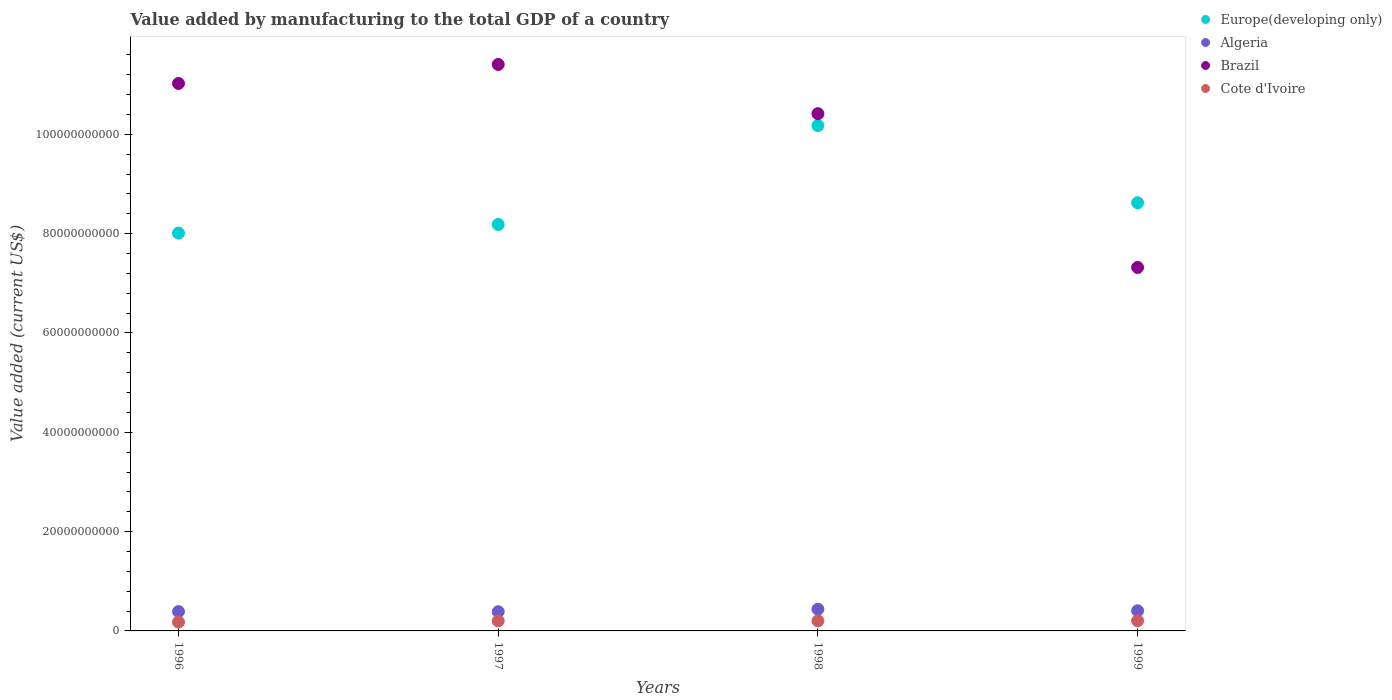Is the number of dotlines equal to the number of legend labels?
Your response must be concise. Yes. What is the value added by manufacturing to the total GDP in Algeria in 1997?
Make the answer very short. 3.87e+09. Across all years, what is the maximum value added by manufacturing to the total GDP in Europe(developing only)?
Keep it short and to the point. 1.02e+11. Across all years, what is the minimum value added by manufacturing to the total GDP in Cote d'Ivoire?
Keep it short and to the point. 1.77e+09. What is the total value added by manufacturing to the total GDP in Cote d'Ivoire in the graph?
Offer a terse response. 7.89e+09. What is the difference between the value added by manufacturing to the total GDP in Brazil in 1996 and that in 1998?
Give a very brief answer. 6.09e+09. What is the difference between the value added by manufacturing to the total GDP in Algeria in 1999 and the value added by manufacturing to the total GDP in Brazil in 1996?
Offer a terse response. -1.06e+11. What is the average value added by manufacturing to the total GDP in Brazil per year?
Give a very brief answer. 1.00e+11. In the year 1996, what is the difference between the value added by manufacturing to the total GDP in Brazil and value added by manufacturing to the total GDP in Europe(developing only)?
Make the answer very short. 3.01e+1. What is the ratio of the value added by manufacturing to the total GDP in Brazil in 1997 to that in 1999?
Keep it short and to the point. 1.56. Is the value added by manufacturing to the total GDP in Algeria in 1998 less than that in 1999?
Your answer should be very brief. No. What is the difference between the highest and the second highest value added by manufacturing to the total GDP in Cote d'Ivoire?
Provide a short and direct response. 8.79e+06. What is the difference between the highest and the lowest value added by manufacturing to the total GDP in Brazil?
Offer a terse response. 4.09e+1. Is the sum of the value added by manufacturing to the total GDP in Cote d'Ivoire in 1996 and 1998 greater than the maximum value added by manufacturing to the total GDP in Brazil across all years?
Give a very brief answer. No. Is the value added by manufacturing to the total GDP in Algeria strictly less than the value added by manufacturing to the total GDP in Europe(developing only) over the years?
Offer a terse response. Yes. How many years are there in the graph?
Offer a very short reply. 4. What is the difference between two consecutive major ticks on the Y-axis?
Your answer should be compact. 2.00e+1. Are the values on the major ticks of Y-axis written in scientific E-notation?
Make the answer very short. No. Does the graph contain any zero values?
Your answer should be very brief. No. Where does the legend appear in the graph?
Ensure brevity in your answer.  Top right. What is the title of the graph?
Your response must be concise. Value added by manufacturing to the total GDP of a country. What is the label or title of the Y-axis?
Ensure brevity in your answer.  Value added (current US$). What is the Value added (current US$) of Europe(developing only) in 1996?
Make the answer very short. 8.01e+1. What is the Value added (current US$) of Algeria in 1996?
Ensure brevity in your answer.  3.90e+09. What is the Value added (current US$) of Brazil in 1996?
Your answer should be very brief. 1.10e+11. What is the Value added (current US$) of Cote d'Ivoire in 1996?
Offer a terse response. 1.77e+09. What is the Value added (current US$) of Europe(developing only) in 1997?
Your response must be concise. 8.18e+1. What is the Value added (current US$) of Algeria in 1997?
Make the answer very short. 3.87e+09. What is the Value added (current US$) in Brazil in 1997?
Provide a short and direct response. 1.14e+11. What is the Value added (current US$) in Cote d'Ivoire in 1997?
Make the answer very short. 2.03e+09. What is the Value added (current US$) of Europe(developing only) in 1998?
Keep it short and to the point. 1.02e+11. What is the Value added (current US$) in Algeria in 1998?
Make the answer very short. 4.37e+09. What is the Value added (current US$) of Brazil in 1998?
Your response must be concise. 1.04e+11. What is the Value added (current US$) in Cote d'Ivoire in 1998?
Your response must be concise. 2.04e+09. What is the Value added (current US$) of Europe(developing only) in 1999?
Provide a succinct answer. 8.62e+1. What is the Value added (current US$) of Algeria in 1999?
Your response must be concise. 4.06e+09. What is the Value added (current US$) in Brazil in 1999?
Your answer should be compact. 7.32e+1. What is the Value added (current US$) of Cote d'Ivoire in 1999?
Your answer should be very brief. 2.05e+09. Across all years, what is the maximum Value added (current US$) of Europe(developing only)?
Give a very brief answer. 1.02e+11. Across all years, what is the maximum Value added (current US$) of Algeria?
Your answer should be very brief. 4.37e+09. Across all years, what is the maximum Value added (current US$) of Brazil?
Offer a very short reply. 1.14e+11. Across all years, what is the maximum Value added (current US$) of Cote d'Ivoire?
Your answer should be compact. 2.05e+09. Across all years, what is the minimum Value added (current US$) in Europe(developing only)?
Your response must be concise. 8.01e+1. Across all years, what is the minimum Value added (current US$) in Algeria?
Offer a very short reply. 3.87e+09. Across all years, what is the minimum Value added (current US$) of Brazil?
Make the answer very short. 7.32e+1. Across all years, what is the minimum Value added (current US$) in Cote d'Ivoire?
Your answer should be compact. 1.77e+09. What is the total Value added (current US$) in Europe(developing only) in the graph?
Offer a very short reply. 3.50e+11. What is the total Value added (current US$) in Algeria in the graph?
Give a very brief answer. 1.62e+1. What is the total Value added (current US$) of Brazil in the graph?
Offer a terse response. 4.02e+11. What is the total Value added (current US$) in Cote d'Ivoire in the graph?
Make the answer very short. 7.89e+09. What is the difference between the Value added (current US$) of Europe(developing only) in 1996 and that in 1997?
Provide a short and direct response. -1.74e+09. What is the difference between the Value added (current US$) in Algeria in 1996 and that in 1997?
Provide a short and direct response. 3.00e+07. What is the difference between the Value added (current US$) of Brazil in 1996 and that in 1997?
Your response must be concise. -3.82e+09. What is the difference between the Value added (current US$) of Cote d'Ivoire in 1996 and that in 1997?
Give a very brief answer. -2.55e+08. What is the difference between the Value added (current US$) in Europe(developing only) in 1996 and that in 1998?
Your answer should be compact. -2.17e+1. What is the difference between the Value added (current US$) in Algeria in 1996 and that in 1998?
Your answer should be very brief. -4.74e+08. What is the difference between the Value added (current US$) in Brazil in 1996 and that in 1998?
Provide a succinct answer. 6.09e+09. What is the difference between the Value added (current US$) of Cote d'Ivoire in 1996 and that in 1998?
Make the answer very short. -2.71e+08. What is the difference between the Value added (current US$) of Europe(developing only) in 1996 and that in 1999?
Keep it short and to the point. -6.11e+09. What is the difference between the Value added (current US$) of Algeria in 1996 and that in 1999?
Make the answer very short. -1.64e+08. What is the difference between the Value added (current US$) in Brazil in 1996 and that in 1999?
Offer a very short reply. 3.71e+1. What is the difference between the Value added (current US$) in Cote d'Ivoire in 1996 and that in 1999?
Provide a short and direct response. -2.80e+08. What is the difference between the Value added (current US$) of Europe(developing only) in 1997 and that in 1998?
Offer a very short reply. -1.99e+1. What is the difference between the Value added (current US$) in Algeria in 1997 and that in 1998?
Provide a short and direct response. -5.04e+08. What is the difference between the Value added (current US$) of Brazil in 1997 and that in 1998?
Provide a succinct answer. 9.91e+09. What is the difference between the Value added (current US$) of Cote d'Ivoire in 1997 and that in 1998?
Your answer should be very brief. -1.64e+07. What is the difference between the Value added (current US$) in Europe(developing only) in 1997 and that in 1999?
Your answer should be very brief. -4.37e+09. What is the difference between the Value added (current US$) of Algeria in 1997 and that in 1999?
Your answer should be compact. -1.94e+08. What is the difference between the Value added (current US$) in Brazil in 1997 and that in 1999?
Provide a succinct answer. 4.09e+1. What is the difference between the Value added (current US$) in Cote d'Ivoire in 1997 and that in 1999?
Provide a short and direct response. -2.52e+07. What is the difference between the Value added (current US$) of Europe(developing only) in 1998 and that in 1999?
Provide a succinct answer. 1.55e+1. What is the difference between the Value added (current US$) in Algeria in 1998 and that in 1999?
Your answer should be very brief. 3.10e+08. What is the difference between the Value added (current US$) in Brazil in 1998 and that in 1999?
Ensure brevity in your answer.  3.10e+1. What is the difference between the Value added (current US$) of Cote d'Ivoire in 1998 and that in 1999?
Make the answer very short. -8.79e+06. What is the difference between the Value added (current US$) of Europe(developing only) in 1996 and the Value added (current US$) of Algeria in 1997?
Make the answer very short. 7.62e+1. What is the difference between the Value added (current US$) of Europe(developing only) in 1996 and the Value added (current US$) of Brazil in 1997?
Offer a terse response. -3.40e+1. What is the difference between the Value added (current US$) in Europe(developing only) in 1996 and the Value added (current US$) in Cote d'Ivoire in 1997?
Your answer should be very brief. 7.81e+1. What is the difference between the Value added (current US$) of Algeria in 1996 and the Value added (current US$) of Brazil in 1997?
Offer a very short reply. -1.10e+11. What is the difference between the Value added (current US$) in Algeria in 1996 and the Value added (current US$) in Cote d'Ivoire in 1997?
Give a very brief answer. 1.87e+09. What is the difference between the Value added (current US$) in Brazil in 1996 and the Value added (current US$) in Cote d'Ivoire in 1997?
Offer a terse response. 1.08e+11. What is the difference between the Value added (current US$) in Europe(developing only) in 1996 and the Value added (current US$) in Algeria in 1998?
Provide a short and direct response. 7.57e+1. What is the difference between the Value added (current US$) in Europe(developing only) in 1996 and the Value added (current US$) in Brazil in 1998?
Your answer should be very brief. -2.40e+1. What is the difference between the Value added (current US$) in Europe(developing only) in 1996 and the Value added (current US$) in Cote d'Ivoire in 1998?
Offer a terse response. 7.81e+1. What is the difference between the Value added (current US$) of Algeria in 1996 and the Value added (current US$) of Brazil in 1998?
Provide a short and direct response. -1.00e+11. What is the difference between the Value added (current US$) in Algeria in 1996 and the Value added (current US$) in Cote d'Ivoire in 1998?
Your response must be concise. 1.86e+09. What is the difference between the Value added (current US$) of Brazil in 1996 and the Value added (current US$) of Cote d'Ivoire in 1998?
Keep it short and to the point. 1.08e+11. What is the difference between the Value added (current US$) in Europe(developing only) in 1996 and the Value added (current US$) in Algeria in 1999?
Make the answer very short. 7.60e+1. What is the difference between the Value added (current US$) in Europe(developing only) in 1996 and the Value added (current US$) in Brazil in 1999?
Ensure brevity in your answer.  6.92e+09. What is the difference between the Value added (current US$) of Europe(developing only) in 1996 and the Value added (current US$) of Cote d'Ivoire in 1999?
Ensure brevity in your answer.  7.81e+1. What is the difference between the Value added (current US$) in Algeria in 1996 and the Value added (current US$) in Brazil in 1999?
Your response must be concise. -6.93e+1. What is the difference between the Value added (current US$) in Algeria in 1996 and the Value added (current US$) in Cote d'Ivoire in 1999?
Your answer should be very brief. 1.85e+09. What is the difference between the Value added (current US$) in Brazil in 1996 and the Value added (current US$) in Cote d'Ivoire in 1999?
Your answer should be very brief. 1.08e+11. What is the difference between the Value added (current US$) in Europe(developing only) in 1997 and the Value added (current US$) in Algeria in 1998?
Provide a succinct answer. 7.75e+1. What is the difference between the Value added (current US$) in Europe(developing only) in 1997 and the Value added (current US$) in Brazil in 1998?
Keep it short and to the point. -2.23e+1. What is the difference between the Value added (current US$) in Europe(developing only) in 1997 and the Value added (current US$) in Cote d'Ivoire in 1998?
Offer a very short reply. 7.98e+1. What is the difference between the Value added (current US$) of Algeria in 1997 and the Value added (current US$) of Brazil in 1998?
Provide a short and direct response. -1.00e+11. What is the difference between the Value added (current US$) in Algeria in 1997 and the Value added (current US$) in Cote d'Ivoire in 1998?
Keep it short and to the point. 1.83e+09. What is the difference between the Value added (current US$) of Brazil in 1997 and the Value added (current US$) of Cote d'Ivoire in 1998?
Provide a succinct answer. 1.12e+11. What is the difference between the Value added (current US$) in Europe(developing only) in 1997 and the Value added (current US$) in Algeria in 1999?
Offer a terse response. 7.78e+1. What is the difference between the Value added (current US$) in Europe(developing only) in 1997 and the Value added (current US$) in Brazil in 1999?
Your answer should be very brief. 8.66e+09. What is the difference between the Value added (current US$) of Europe(developing only) in 1997 and the Value added (current US$) of Cote d'Ivoire in 1999?
Provide a short and direct response. 7.98e+1. What is the difference between the Value added (current US$) in Algeria in 1997 and the Value added (current US$) in Brazil in 1999?
Offer a terse response. -6.93e+1. What is the difference between the Value added (current US$) of Algeria in 1997 and the Value added (current US$) of Cote d'Ivoire in 1999?
Your answer should be very brief. 1.82e+09. What is the difference between the Value added (current US$) in Brazil in 1997 and the Value added (current US$) in Cote d'Ivoire in 1999?
Keep it short and to the point. 1.12e+11. What is the difference between the Value added (current US$) in Europe(developing only) in 1998 and the Value added (current US$) in Algeria in 1999?
Your answer should be very brief. 9.77e+1. What is the difference between the Value added (current US$) of Europe(developing only) in 1998 and the Value added (current US$) of Brazil in 1999?
Ensure brevity in your answer.  2.86e+1. What is the difference between the Value added (current US$) of Europe(developing only) in 1998 and the Value added (current US$) of Cote d'Ivoire in 1999?
Offer a terse response. 9.97e+1. What is the difference between the Value added (current US$) of Algeria in 1998 and the Value added (current US$) of Brazil in 1999?
Ensure brevity in your answer.  -6.88e+1. What is the difference between the Value added (current US$) in Algeria in 1998 and the Value added (current US$) in Cote d'Ivoire in 1999?
Offer a terse response. 2.32e+09. What is the difference between the Value added (current US$) of Brazil in 1998 and the Value added (current US$) of Cote d'Ivoire in 1999?
Your answer should be compact. 1.02e+11. What is the average Value added (current US$) of Europe(developing only) per year?
Offer a very short reply. 8.75e+1. What is the average Value added (current US$) in Algeria per year?
Ensure brevity in your answer.  4.05e+09. What is the average Value added (current US$) in Brazil per year?
Your response must be concise. 1.00e+11. What is the average Value added (current US$) in Cote d'Ivoire per year?
Keep it short and to the point. 1.97e+09. In the year 1996, what is the difference between the Value added (current US$) of Europe(developing only) and Value added (current US$) of Algeria?
Your answer should be very brief. 7.62e+1. In the year 1996, what is the difference between the Value added (current US$) of Europe(developing only) and Value added (current US$) of Brazil?
Offer a terse response. -3.01e+1. In the year 1996, what is the difference between the Value added (current US$) of Europe(developing only) and Value added (current US$) of Cote d'Ivoire?
Give a very brief answer. 7.83e+1. In the year 1996, what is the difference between the Value added (current US$) in Algeria and Value added (current US$) in Brazil?
Ensure brevity in your answer.  -1.06e+11. In the year 1996, what is the difference between the Value added (current US$) of Algeria and Value added (current US$) of Cote d'Ivoire?
Your answer should be very brief. 2.13e+09. In the year 1996, what is the difference between the Value added (current US$) in Brazil and Value added (current US$) in Cote d'Ivoire?
Offer a very short reply. 1.08e+11. In the year 1997, what is the difference between the Value added (current US$) in Europe(developing only) and Value added (current US$) in Algeria?
Ensure brevity in your answer.  7.80e+1. In the year 1997, what is the difference between the Value added (current US$) of Europe(developing only) and Value added (current US$) of Brazil?
Your answer should be very brief. -3.22e+1. In the year 1997, what is the difference between the Value added (current US$) in Europe(developing only) and Value added (current US$) in Cote d'Ivoire?
Make the answer very short. 7.98e+1. In the year 1997, what is the difference between the Value added (current US$) in Algeria and Value added (current US$) in Brazil?
Keep it short and to the point. -1.10e+11. In the year 1997, what is the difference between the Value added (current US$) in Algeria and Value added (current US$) in Cote d'Ivoire?
Make the answer very short. 1.84e+09. In the year 1997, what is the difference between the Value added (current US$) in Brazil and Value added (current US$) in Cote d'Ivoire?
Your answer should be compact. 1.12e+11. In the year 1998, what is the difference between the Value added (current US$) in Europe(developing only) and Value added (current US$) in Algeria?
Your response must be concise. 9.74e+1. In the year 1998, what is the difference between the Value added (current US$) of Europe(developing only) and Value added (current US$) of Brazil?
Give a very brief answer. -2.38e+09. In the year 1998, what is the difference between the Value added (current US$) of Europe(developing only) and Value added (current US$) of Cote d'Ivoire?
Offer a terse response. 9.97e+1. In the year 1998, what is the difference between the Value added (current US$) of Algeria and Value added (current US$) of Brazil?
Ensure brevity in your answer.  -9.98e+1. In the year 1998, what is the difference between the Value added (current US$) of Algeria and Value added (current US$) of Cote d'Ivoire?
Provide a succinct answer. 2.33e+09. In the year 1998, what is the difference between the Value added (current US$) of Brazil and Value added (current US$) of Cote d'Ivoire?
Provide a short and direct response. 1.02e+11. In the year 1999, what is the difference between the Value added (current US$) of Europe(developing only) and Value added (current US$) of Algeria?
Provide a short and direct response. 8.22e+1. In the year 1999, what is the difference between the Value added (current US$) of Europe(developing only) and Value added (current US$) of Brazil?
Offer a terse response. 1.30e+1. In the year 1999, what is the difference between the Value added (current US$) in Europe(developing only) and Value added (current US$) in Cote d'Ivoire?
Ensure brevity in your answer.  8.42e+1. In the year 1999, what is the difference between the Value added (current US$) of Algeria and Value added (current US$) of Brazil?
Ensure brevity in your answer.  -6.91e+1. In the year 1999, what is the difference between the Value added (current US$) of Algeria and Value added (current US$) of Cote d'Ivoire?
Provide a short and direct response. 2.01e+09. In the year 1999, what is the difference between the Value added (current US$) in Brazil and Value added (current US$) in Cote d'Ivoire?
Your answer should be very brief. 7.11e+1. What is the ratio of the Value added (current US$) in Europe(developing only) in 1996 to that in 1997?
Give a very brief answer. 0.98. What is the ratio of the Value added (current US$) of Algeria in 1996 to that in 1997?
Make the answer very short. 1.01. What is the ratio of the Value added (current US$) in Brazil in 1996 to that in 1997?
Make the answer very short. 0.97. What is the ratio of the Value added (current US$) in Cote d'Ivoire in 1996 to that in 1997?
Your answer should be compact. 0.87. What is the ratio of the Value added (current US$) of Europe(developing only) in 1996 to that in 1998?
Offer a terse response. 0.79. What is the ratio of the Value added (current US$) of Algeria in 1996 to that in 1998?
Make the answer very short. 0.89. What is the ratio of the Value added (current US$) in Brazil in 1996 to that in 1998?
Make the answer very short. 1.06. What is the ratio of the Value added (current US$) of Cote d'Ivoire in 1996 to that in 1998?
Make the answer very short. 0.87. What is the ratio of the Value added (current US$) in Europe(developing only) in 1996 to that in 1999?
Give a very brief answer. 0.93. What is the ratio of the Value added (current US$) of Algeria in 1996 to that in 1999?
Your answer should be compact. 0.96. What is the ratio of the Value added (current US$) in Brazil in 1996 to that in 1999?
Your answer should be very brief. 1.51. What is the ratio of the Value added (current US$) in Cote d'Ivoire in 1996 to that in 1999?
Your answer should be compact. 0.86. What is the ratio of the Value added (current US$) of Europe(developing only) in 1997 to that in 1998?
Make the answer very short. 0.8. What is the ratio of the Value added (current US$) of Algeria in 1997 to that in 1998?
Keep it short and to the point. 0.88. What is the ratio of the Value added (current US$) in Brazil in 1997 to that in 1998?
Give a very brief answer. 1.1. What is the ratio of the Value added (current US$) of Cote d'Ivoire in 1997 to that in 1998?
Ensure brevity in your answer.  0.99. What is the ratio of the Value added (current US$) of Europe(developing only) in 1997 to that in 1999?
Keep it short and to the point. 0.95. What is the ratio of the Value added (current US$) of Algeria in 1997 to that in 1999?
Keep it short and to the point. 0.95. What is the ratio of the Value added (current US$) of Brazil in 1997 to that in 1999?
Your response must be concise. 1.56. What is the ratio of the Value added (current US$) of Cote d'Ivoire in 1997 to that in 1999?
Your answer should be very brief. 0.99. What is the ratio of the Value added (current US$) of Europe(developing only) in 1998 to that in 1999?
Make the answer very short. 1.18. What is the ratio of the Value added (current US$) of Algeria in 1998 to that in 1999?
Keep it short and to the point. 1.08. What is the ratio of the Value added (current US$) of Brazil in 1998 to that in 1999?
Keep it short and to the point. 1.42. What is the difference between the highest and the second highest Value added (current US$) in Europe(developing only)?
Your answer should be compact. 1.55e+1. What is the difference between the highest and the second highest Value added (current US$) in Algeria?
Your response must be concise. 3.10e+08. What is the difference between the highest and the second highest Value added (current US$) in Brazil?
Give a very brief answer. 3.82e+09. What is the difference between the highest and the second highest Value added (current US$) in Cote d'Ivoire?
Keep it short and to the point. 8.79e+06. What is the difference between the highest and the lowest Value added (current US$) in Europe(developing only)?
Provide a short and direct response. 2.17e+1. What is the difference between the highest and the lowest Value added (current US$) of Algeria?
Give a very brief answer. 5.04e+08. What is the difference between the highest and the lowest Value added (current US$) of Brazil?
Your response must be concise. 4.09e+1. What is the difference between the highest and the lowest Value added (current US$) in Cote d'Ivoire?
Your response must be concise. 2.80e+08. 